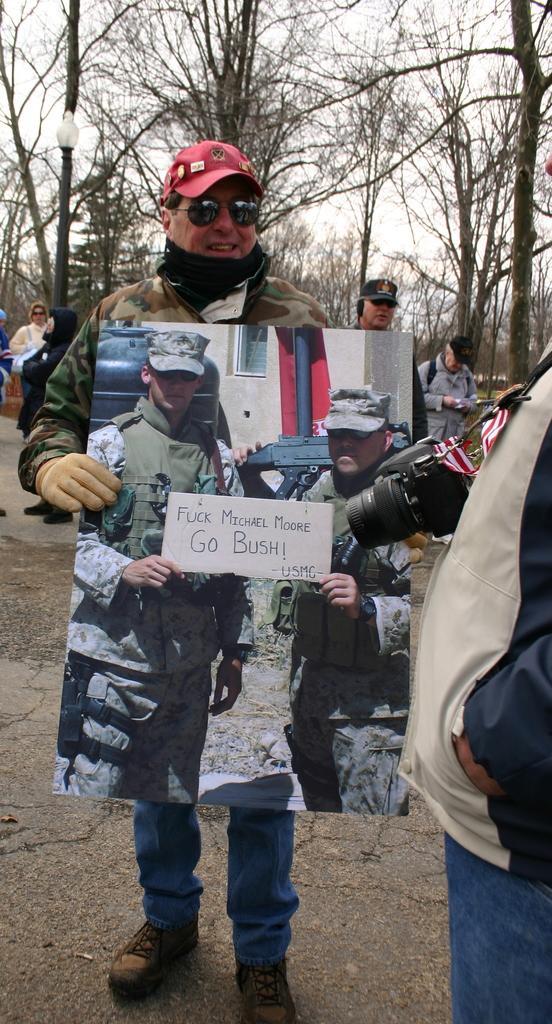Describe this image in one or two sentences. Here a man is standing, he wore a coat, red color cap and he is holding a picture, in that 2 men are standing. Behind it, there are trees. 